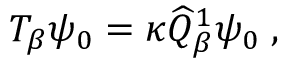Convert formula to latex. <formula><loc_0><loc_0><loc_500><loc_500>T _ { \beta } \psi _ { 0 } = \kappa \widehat { Q } _ { \beta } ^ { 1 } \psi _ { 0 } \, ,</formula> 